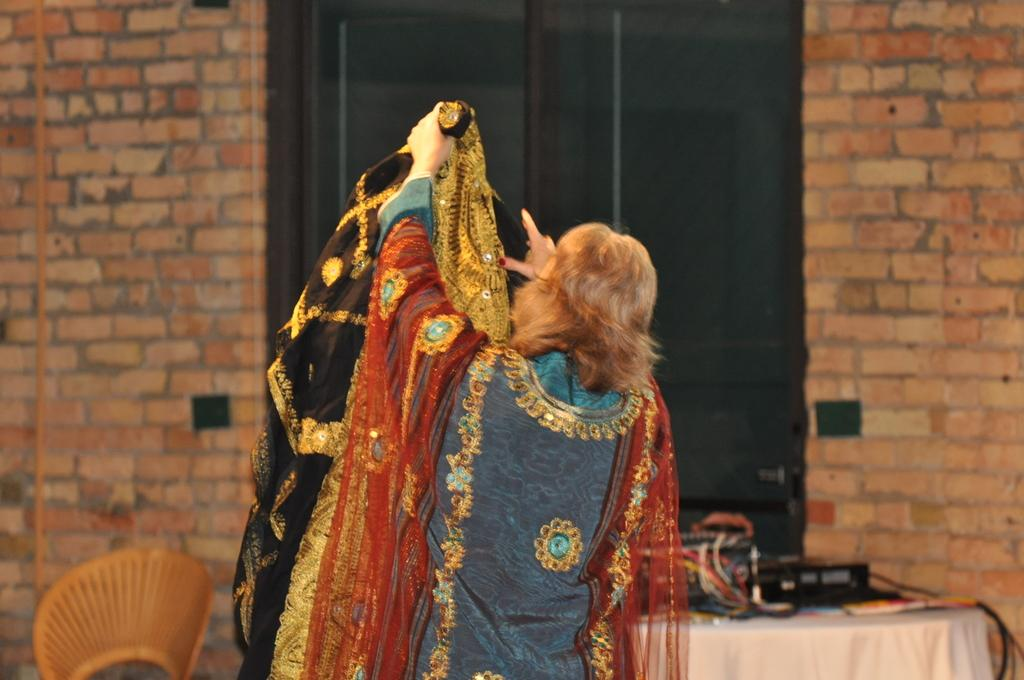What is the person in the image holding? The person is holding a cloth in the image. What is on the table in the image? There is a cloth, cables, and a device on the table in the image. What is the purpose of the cloth on the table? The cloth on the table might be used for cleaning or covering the device. What can be seen in the background of the image? There is a wall visible in the background of the image. What does the person's son do in the image? There is no mention of a son in the image or the provided facts, so we cannot answer this question. 